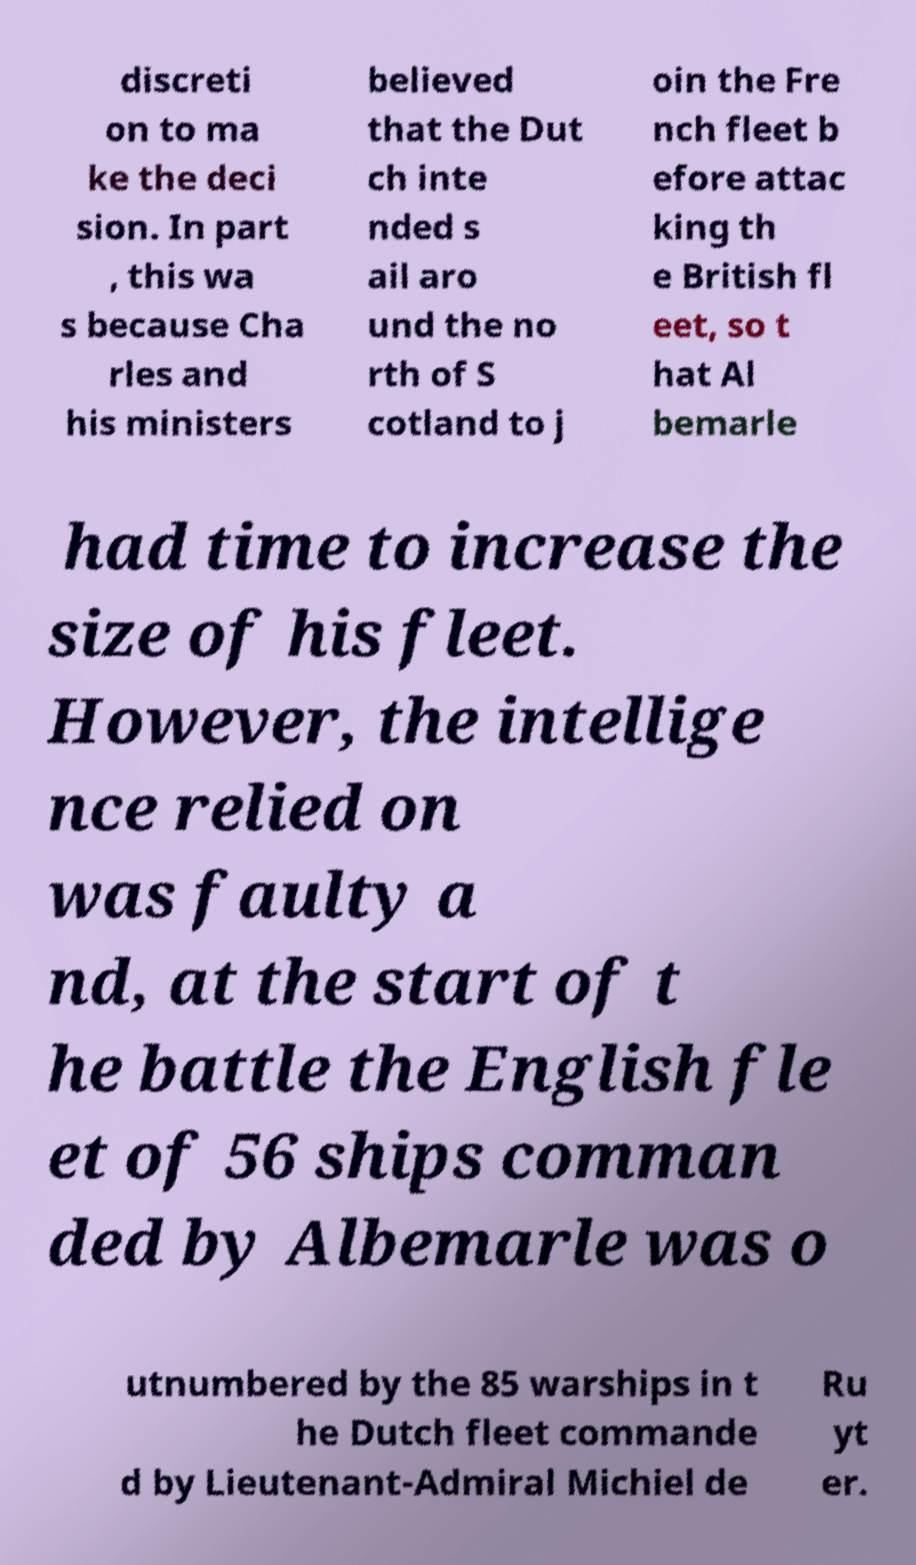Please read and relay the text visible in this image. What does it say? discreti on to ma ke the deci sion. In part , this wa s because Cha rles and his ministers believed that the Dut ch inte nded s ail aro und the no rth of S cotland to j oin the Fre nch fleet b efore attac king th e British fl eet, so t hat Al bemarle had time to increase the size of his fleet. However, the intellige nce relied on was faulty a nd, at the start of t he battle the English fle et of 56 ships comman ded by Albemarle was o utnumbered by the 85 warships in t he Dutch fleet commande d by Lieutenant-Admiral Michiel de Ru yt er. 